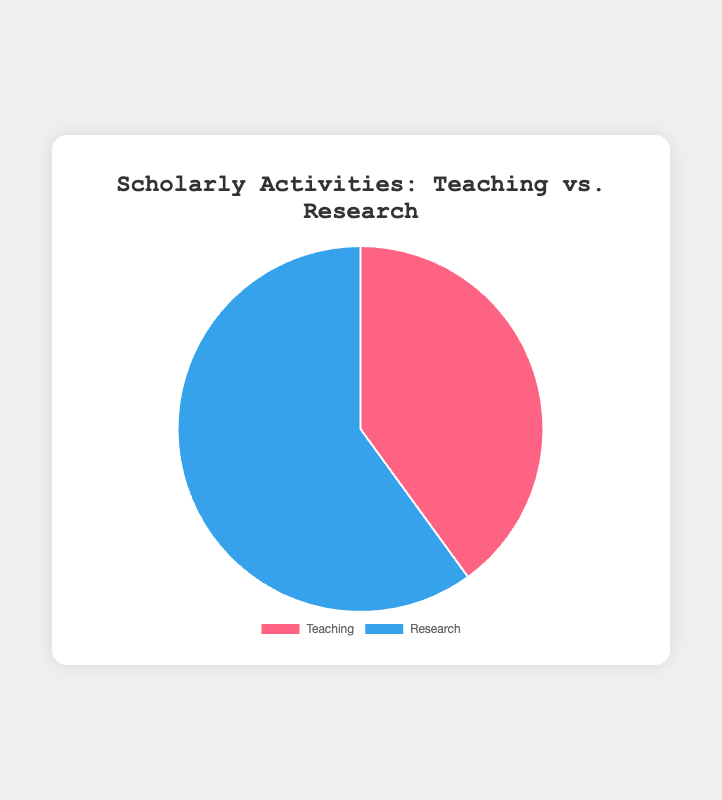What percentage of scholarly activities is devoted to Teaching? The pie chart shows that the portion for Teaching is labeled directly with its percentage.
Answer: 40% What percentage of scholarly activities is dedicated to Research? The pie chart shows that the portion for Research is labeled directly with its percentage.
Answer: 60% Which activity type has a higher percentage? By comparing the two values given in the pie chart, Research has a higher percentage (60%) compared to Teaching (40%).
Answer: Research How much more is the percentage for Research compared to Teaching? To find the difference, subtract the percentage for Teaching from the percentage for Research: 60% - 40% = 20%.
Answer: 20% What is the ratio of Teaching to Research activities? The ratio can be calculated by dividing the percentage for Teaching by that for Research: 40 / 60 = 2 / 3.
Answer: 2/3 If the total number of hours spent on scholarly activities is 100 hours, how many hours are spent on Teaching? Calculate the number of hours based on the percentage: 40% of 100 hours is (40/100) * 100 = 40 hours.
Answer: 40 hours Given the same total of 100 hours, how many hours are spent on Research? Calculate the number of hours based on the percentage: 60% of 100 hours is (60/100) * 100 = 60 hours.
Answer: 60 hours What is the combined percentage of activities devoted to both Teaching and Research? Sum the percentages of Teaching and Research: 40% + 60% = 100%.
Answer: 100% What fraction of the pie chart represents Teaching activities? The fraction can be directly derived from the percentage. Teaching is 40%, which is 40/100 or simplified, 2/5.
Answer: 2/5 Which color represents Research activities in the pie chart? The pie chart uses a specific color for each category. Research is represented by the blue section.
Answer: Blue 